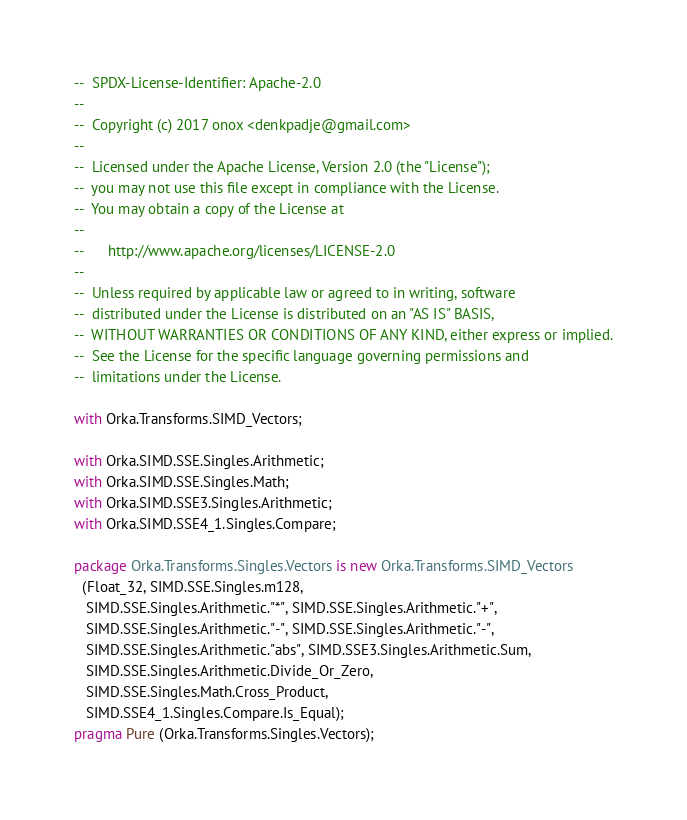Convert code to text. <code><loc_0><loc_0><loc_500><loc_500><_Ada_>--  SPDX-License-Identifier: Apache-2.0
--
--  Copyright (c) 2017 onox <denkpadje@gmail.com>
--
--  Licensed under the Apache License, Version 2.0 (the "License");
--  you may not use this file except in compliance with the License.
--  You may obtain a copy of the License at
--
--      http://www.apache.org/licenses/LICENSE-2.0
--
--  Unless required by applicable law or agreed to in writing, software
--  distributed under the License is distributed on an "AS IS" BASIS,
--  WITHOUT WARRANTIES OR CONDITIONS OF ANY KIND, either express or implied.
--  See the License for the specific language governing permissions and
--  limitations under the License.

with Orka.Transforms.SIMD_Vectors;

with Orka.SIMD.SSE.Singles.Arithmetic;
with Orka.SIMD.SSE.Singles.Math;
with Orka.SIMD.SSE3.Singles.Arithmetic;
with Orka.SIMD.SSE4_1.Singles.Compare;

package Orka.Transforms.Singles.Vectors is new Orka.Transforms.SIMD_Vectors
  (Float_32, SIMD.SSE.Singles.m128,
   SIMD.SSE.Singles.Arithmetic."*", SIMD.SSE.Singles.Arithmetic."+",
   SIMD.SSE.Singles.Arithmetic."-", SIMD.SSE.Singles.Arithmetic."-",
   SIMD.SSE.Singles.Arithmetic."abs", SIMD.SSE3.Singles.Arithmetic.Sum,
   SIMD.SSE.Singles.Arithmetic.Divide_Or_Zero,
   SIMD.SSE.Singles.Math.Cross_Product,
   SIMD.SSE4_1.Singles.Compare.Is_Equal);
pragma Pure (Orka.Transforms.Singles.Vectors);
</code> 